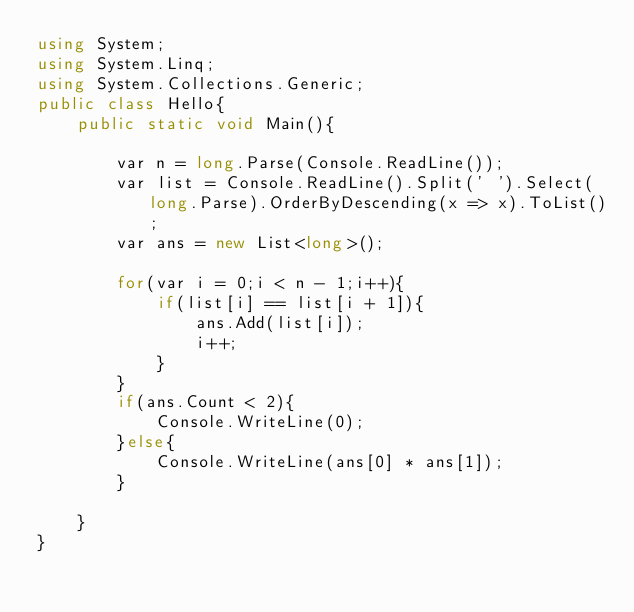Convert code to text. <code><loc_0><loc_0><loc_500><loc_500><_C#_>using System;
using System.Linq;
using System.Collections.Generic;
public class Hello{
    public static void Main(){
        
        var n = long.Parse(Console.ReadLine());
        var list = Console.ReadLine().Split(' ').Select(long.Parse).OrderByDescending(x => x).ToList();
        var ans = new List<long>();
        
        for(var i = 0;i < n - 1;i++){
            if(list[i] == list[i + 1]){
                ans.Add(list[i]);
                i++;
            }
        }
        if(ans.Count < 2){
            Console.WriteLine(0);
        }else{
            Console.WriteLine(ans[0] * ans[1]);
        }
        
    }
}
</code> 